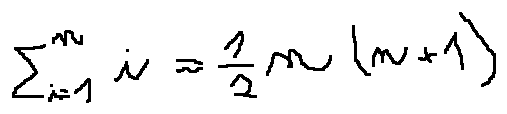<formula> <loc_0><loc_0><loc_500><loc_500>\sum \lim i t s _ { i = 1 } ^ { n } i = \frac { 1 } { 2 } n ( n + 1 )</formula> 